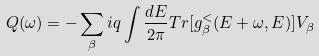<formula> <loc_0><loc_0><loc_500><loc_500>Q ( \omega ) = - \sum _ { \beta } i q \int \frac { d E } { 2 \pi } T r [ g ^ { < } _ { \beta } ( E + \omega , E ) ] V _ { \beta }</formula> 